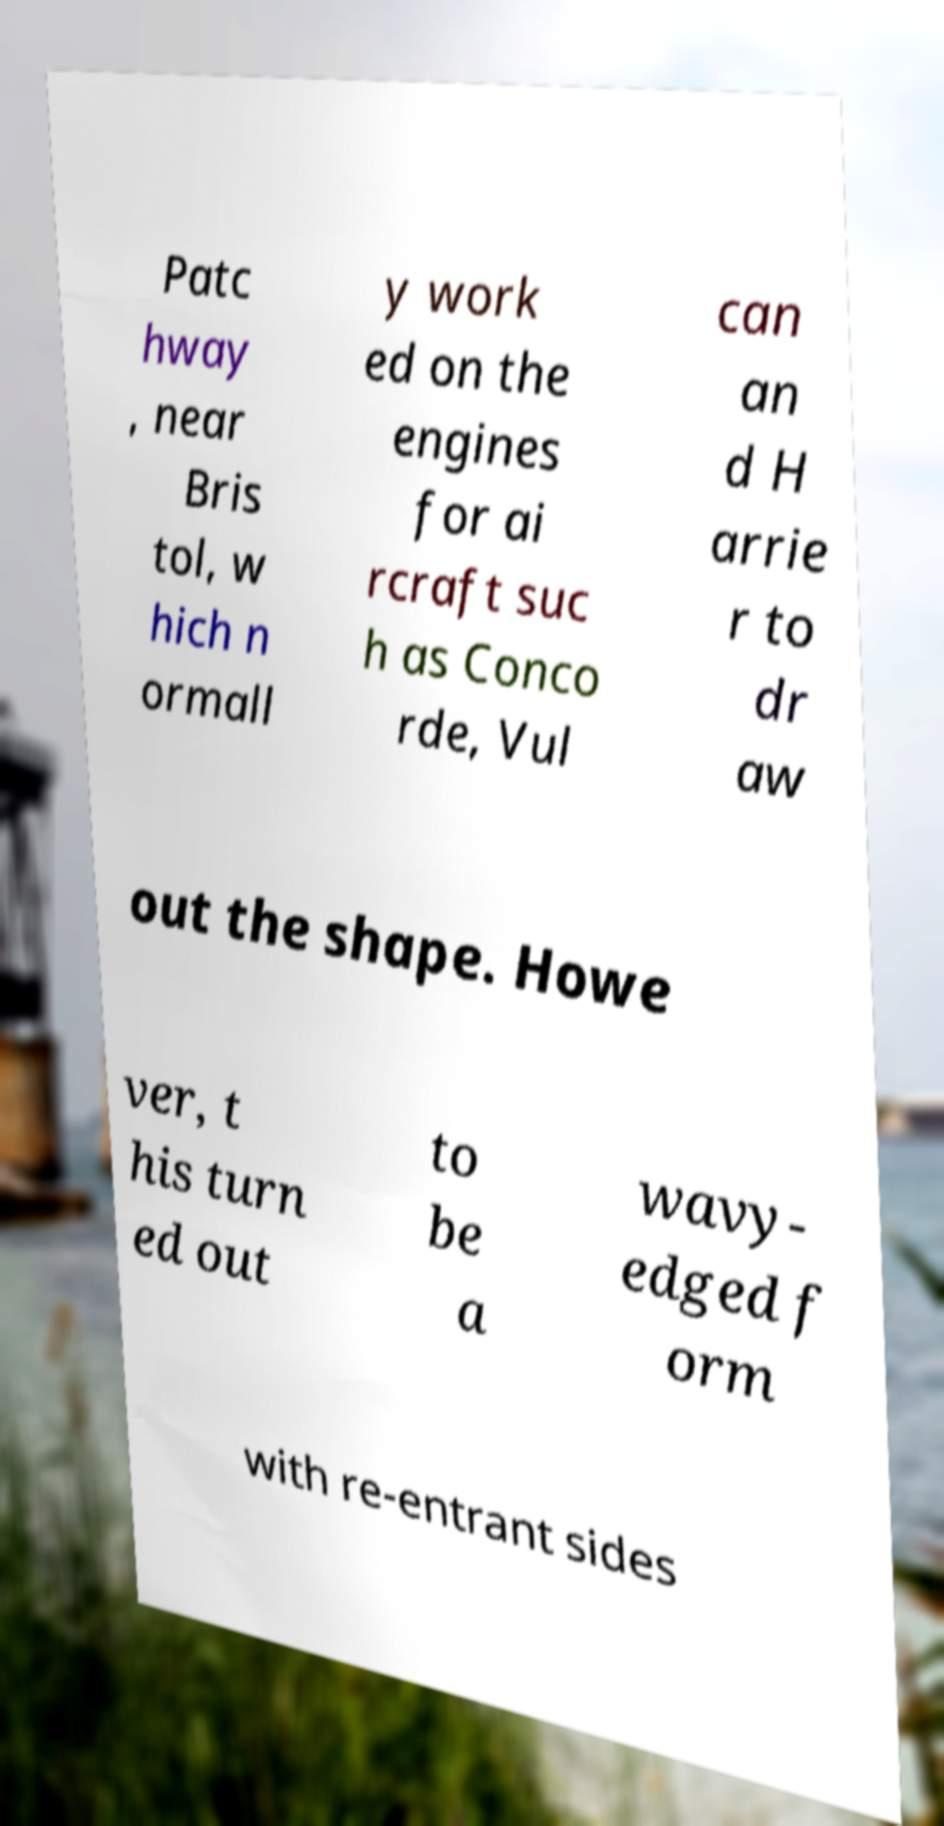I need the written content from this picture converted into text. Can you do that? Patc hway , near Bris tol, w hich n ormall y work ed on the engines for ai rcraft suc h as Conco rde, Vul can an d H arrie r to dr aw out the shape. Howe ver, t his turn ed out to be a wavy- edged f orm with re-entrant sides 